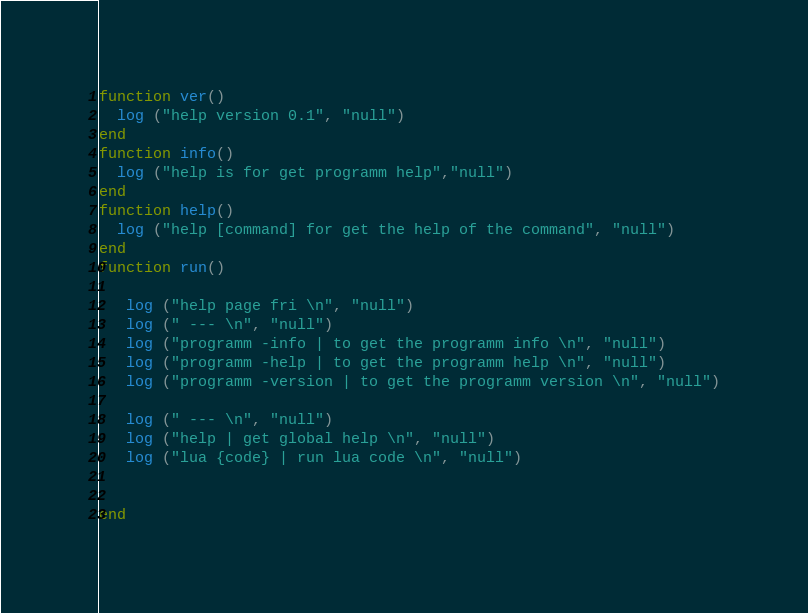<code> <loc_0><loc_0><loc_500><loc_500><_Lua_>function ver()
  log ("help version 0.1", "null")
end
function info()
  log ("help is for get programm help","null")
end
function help()
  log ("help [command] for get the help of the command", "null")
end
function run()

   log ("help page fri \n", "null")
   log (" --- \n", "null")
   log ("programm -info | to get the programm info \n", "null")
   log ("programm -help | to get the programm help \n", "null")
   log ("programm -version | to get the programm version \n", "null")

   log (" --- \n", "null")
   log ("help | get global help \n", "null")
   log ("lua {code} | run lua code \n", "null")


end</code> 